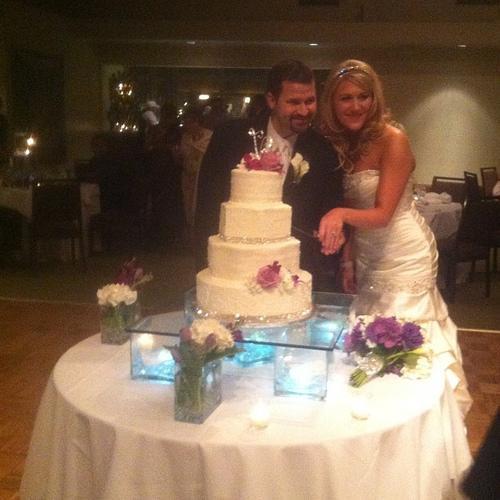How many people are standing by the cake?
Give a very brief answer. 2. 